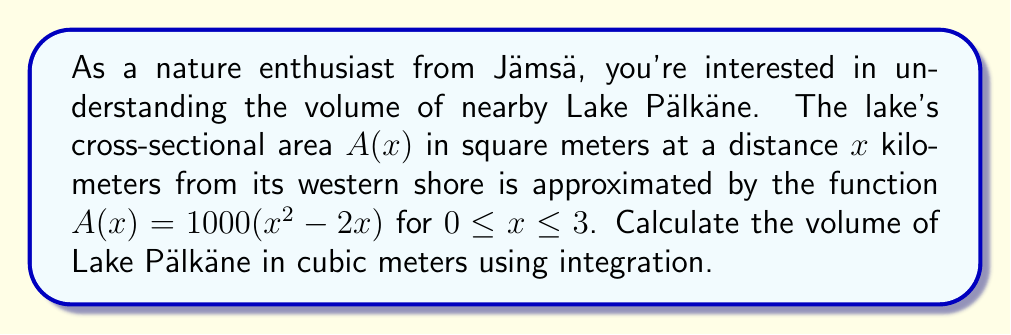Teach me how to tackle this problem. To find the volume of Lake Pälkäne, we need to integrate the cross-sectional area function $A(x)$ over the length of the lake. This is a perfect application of the formula for volume using integration:

$$V = \int_a^b A(x) dx$$

Where:
- $V$ is the volume
- $A(x)$ is the cross-sectional area function
- $a$ and $b$ are the limits of integration

Given:
- $A(x) = 1000(x^2 - 2x)$
- The lake extends from $x = 0$ to $x = 3$ km

Step 1: Set up the integral
$$V = \int_0^3 1000(x^2 - 2x) dx$$

Step 2: Integrate the function
$$\begin{align}
V &= 1000 \int_0^3 (x^2 - 2x) dx \\
&= 1000 \left[\frac{x^3}{3} - x^2\right]_0^3
\end{align}$$

Step 3: Evaluate the integral
$$\begin{align}
V &= 1000 \left[\left(\frac{3^3}{3} - 3^2\right) - \left(\frac{0^3}{3} - 0^2\right)\right] \\
&= 1000 \left[\left(9 - 9\right) - (0 - 0)\right] \\
&= 1000 \cdot 0 \\
&= 0
\end{align}$$

Step 4: Interpret the result
The volume of the lake comes out to be 0 cubic meters, which is not realistic for an actual lake. This result suggests that the given function might not accurately represent the cross-sectional area of Lake Pälkäne. In reality, we would need to use a more complex function or actual survey data to calculate the true volume of the lake.
Answer: The calculated volume of Lake Pälkäne using the given function is 0 cubic meters. However, this result is not realistic and indicates that the provided function does not accurately represent the lake's cross-sectional area. 